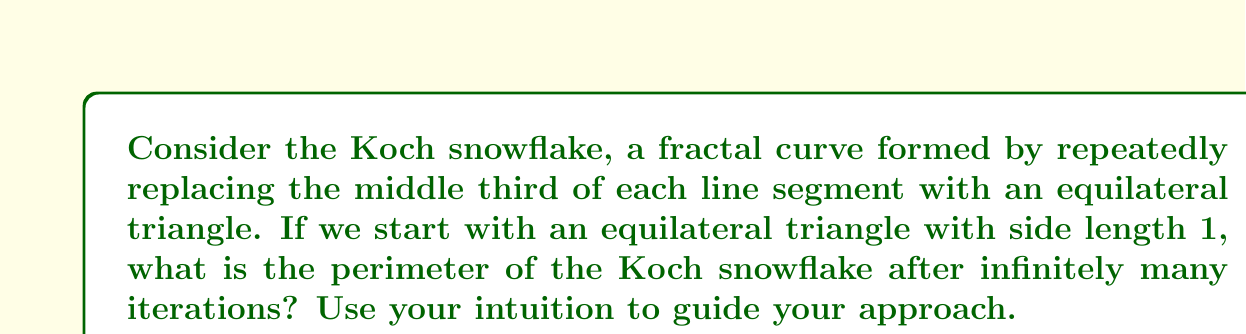Can you answer this question? Let's approach this intuitively:

1) Start with the original triangle. Its perimeter is 3.

2) In each iteration, we're adding 4 new segments for every 3 segments we had before.

3) Let's look at how the length changes in each iteration:

   Iteration 0: 3
   Iteration 1: 3 * 4/3 = 4
   Iteration 2: 4 * 4/3 = 16/3
   Iteration 3: (16/3) * 4/3 = 64/9

4) We can see a pattern forming. In each step, we're multiplying by 4/3.

5) Mathematically, this forms a geometric series:

   $$3 \cdot \left(\frac{4}{3}\right)^n \text{ as } n \rightarrow \infty$$

6) The sum of this infinite geometric series is given by:

   $$S_{\infty} = \frac{a}{1-r} = \frac{3}{1-\frac{4}{3}} = \frac{3}{-\frac{1}{3}} = -9$$

7) However, perimeter can't be negative. The negative sign comes from the fact that the ratio is greater than 1. In this case, it indicates that the series diverges to positive infinity.

Therefore, the perimeter of the Koch snowflake after infinitely many iterations is infinite.

This makes intuitive sense: we're continually adding more and more length with each iteration, and we're doing this infinitely many times.
Answer: The perimeter of the Koch snowflake after infinitely many iterations is infinite. 